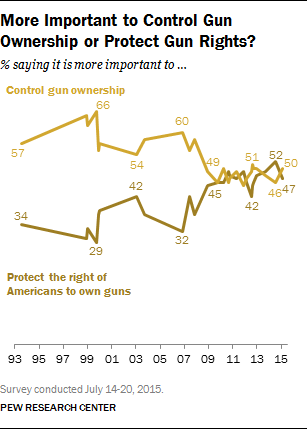Identify some key points in this picture. The rightmost value in the dark brown graph is 47. 